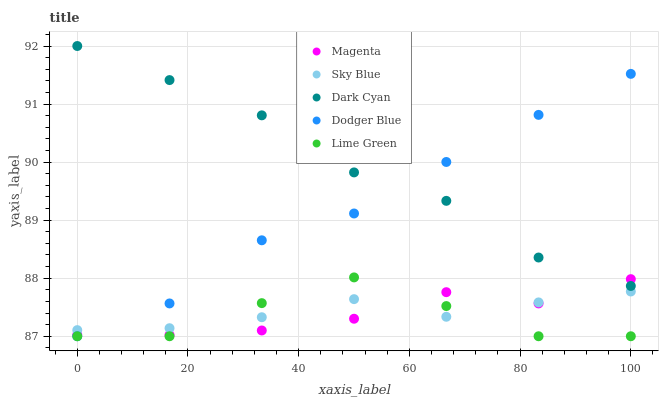Does Lime Green have the minimum area under the curve?
Answer yes or no. Yes. Does Dark Cyan have the maximum area under the curve?
Answer yes or no. Yes. Does Sky Blue have the minimum area under the curve?
Answer yes or no. No. Does Sky Blue have the maximum area under the curve?
Answer yes or no. No. Is Sky Blue the smoothest?
Answer yes or no. Yes. Is Lime Green the roughest?
Answer yes or no. Yes. Is Magenta the smoothest?
Answer yes or no. No. Is Magenta the roughest?
Answer yes or no. No. Does Dodger Blue have the lowest value?
Answer yes or no. Yes. Does Sky Blue have the lowest value?
Answer yes or no. No. Does Dark Cyan have the highest value?
Answer yes or no. Yes. Does Magenta have the highest value?
Answer yes or no. No. Is Lime Green less than Dark Cyan?
Answer yes or no. Yes. Is Dark Cyan greater than Sky Blue?
Answer yes or no. Yes. Does Sky Blue intersect Dodger Blue?
Answer yes or no. Yes. Is Sky Blue less than Dodger Blue?
Answer yes or no. No. Is Sky Blue greater than Dodger Blue?
Answer yes or no. No. Does Lime Green intersect Dark Cyan?
Answer yes or no. No. 